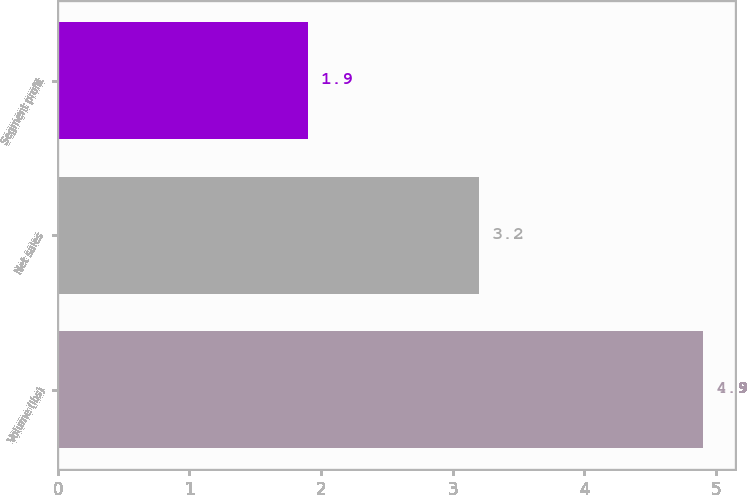Convert chart to OTSL. <chart><loc_0><loc_0><loc_500><loc_500><bar_chart><fcel>Volume (lbs)<fcel>Net sales<fcel>Segment profit<nl><fcel>4.9<fcel>3.2<fcel>1.9<nl></chart> 